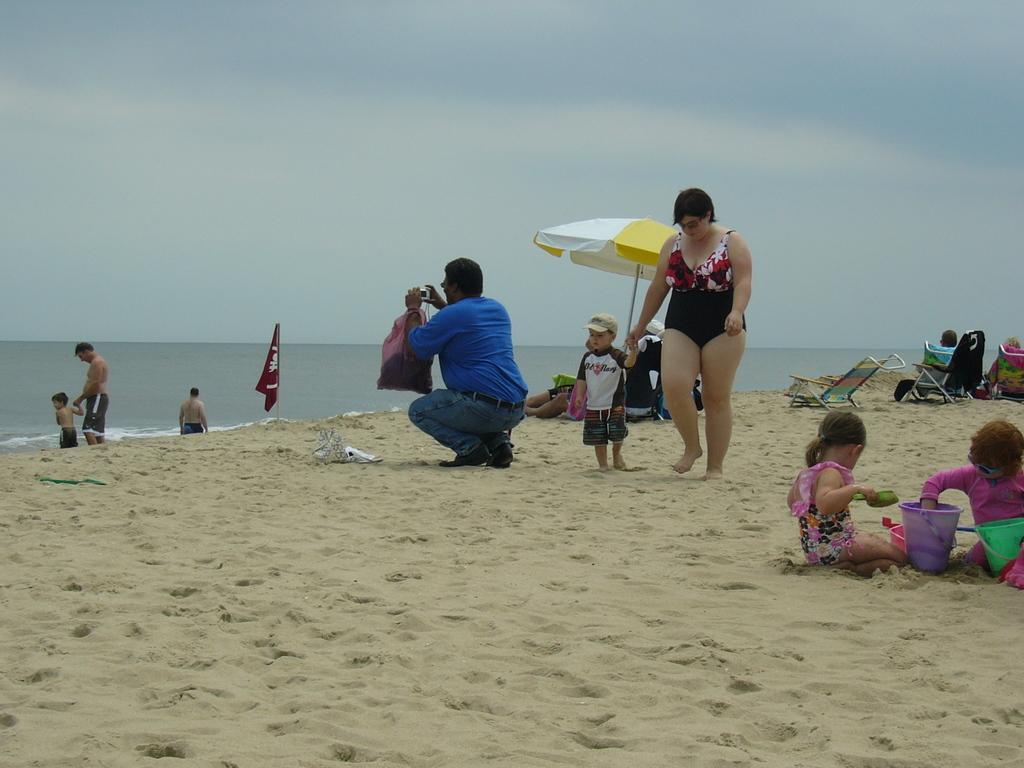Please provide a concise description of this image. This image is clicked at the beach. In the foreground there is sand on the ground. There are people sitting on the chairs under the table umbrellas. In the center there is a man in squat position and holding a camera in his hand. Behind him there is a woman and a kid walking on the ground. To the right there are kids playing in the sand. In the background there is the water. There is a flag on the ground. At the top there is the sky. 